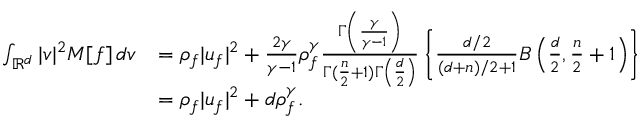<formula> <loc_0><loc_0><loc_500><loc_500>\begin{array} { r l } { \int _ { \mathbb { R } ^ { d } } | v | ^ { 2 } M [ f ] \, d v } & { = \rho _ { f } | u _ { f } | ^ { 2 } + \frac { 2 \gamma } { \gamma - 1 } \rho _ { f } ^ { \gamma } \frac { \Gamma \left ( \frac { \gamma } { \gamma - 1 } \right ) } { \Gamma ( \frac { n } { 2 } + 1 ) \Gamma \left ( \frac { d } { 2 } \right ) } \left \{ \frac { d / 2 } { ( d + n ) / 2 + 1 } B \left ( \frac { d } { 2 } , \frac { n } { 2 } + 1 \right ) \right \} } \\ & { = \rho _ { f } | u _ { f } | ^ { 2 } + d \rho _ { f } ^ { \gamma } . } \end{array}</formula> 